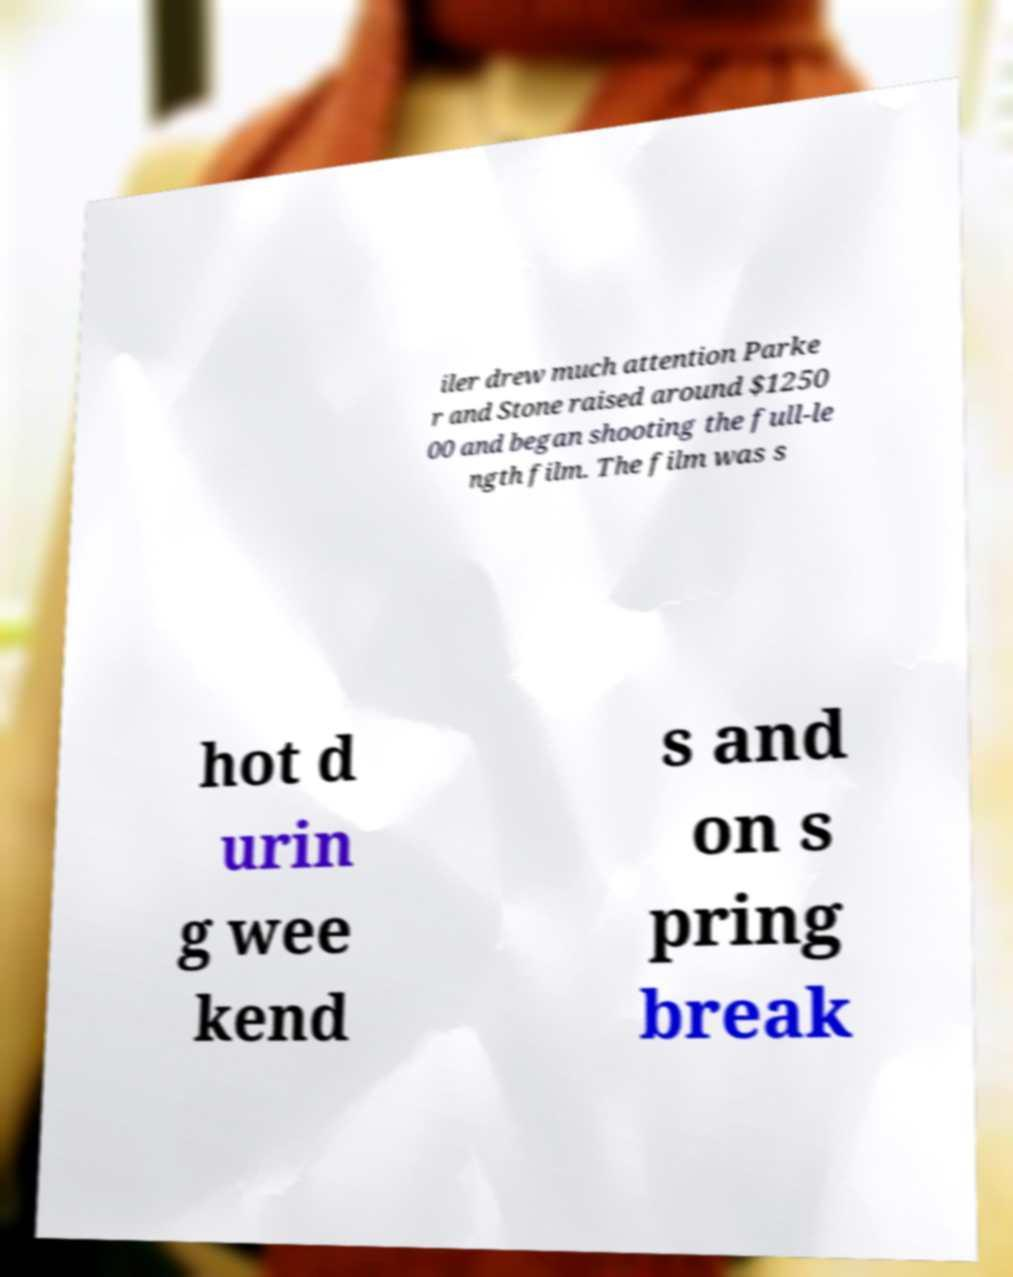Could you assist in decoding the text presented in this image and type it out clearly? iler drew much attention Parke r and Stone raised around $1250 00 and began shooting the full-le ngth film. The film was s hot d urin g wee kend s and on s pring break 